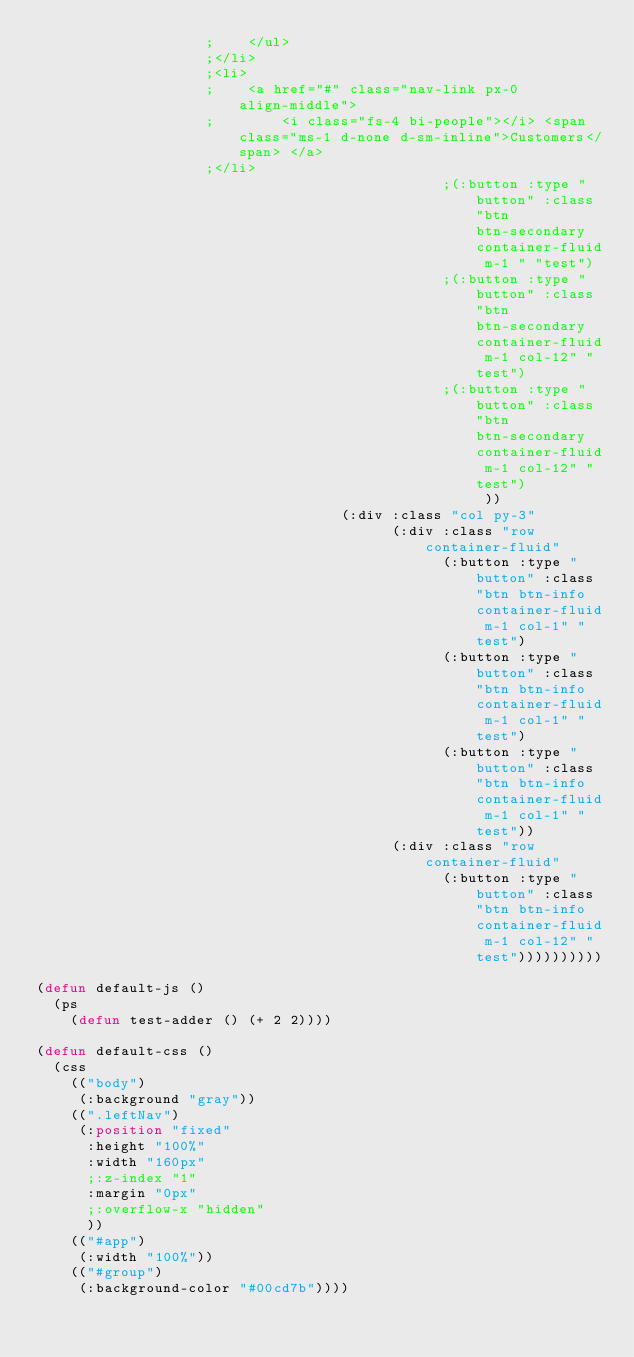<code> <loc_0><loc_0><loc_500><loc_500><_Lisp_>                    ;    </ul>
                    ;</li>
                    ;<li>
                    ;    <a href="#" class="nav-link px-0 align-middle">
                    ;        <i class="fs-4 bi-people"></i> <span class="ms-1 d-none d-sm-inline">Customers</span> </a>
                    ;</li>
                                                ;(:button :type "button" :class "btn btn-secondary container-fluid m-1 " "test")
                                                ;(:button :type "button" :class "btn btn-secondary container-fluid m-1 col-12" "test")
                                                ;(:button :type "button" :class "btn btn-secondary container-fluid m-1 col-12" "test")
                                                     ))
                                    (:div :class "col py-3"
                                          (:div :class "row container-fluid"
                                                (:button :type "button" :class "btn btn-info container-fluid m-1 col-1" "test")
                                                (:button :type "button" :class "btn btn-info container-fluid m-1 col-1" "test")
                                                (:button :type "button" :class "btn btn-info container-fluid m-1 col-1" "test"))
                                          (:div :class "row container-fluid"
                                                (:button :type "button" :class "btn btn-info container-fluid m-1 col-12" "test"))))))))))

(defun default-js ()
  (ps
    (defun test-adder () (+ 2 2))))

(defun default-css ()
  (css
    (("body")
     (:background "gray"))
    ((".leftNav")
     (:position "fixed"
      :height "100%"
      :width "160px"
      ;:z-index "1"
      :margin "0px"
      ;:overflow-x "hidden"
      ))
    (("#app")
     (:width "100%"))
    (("#group")
     (:background-color "#00cd7b"))))
</code> 